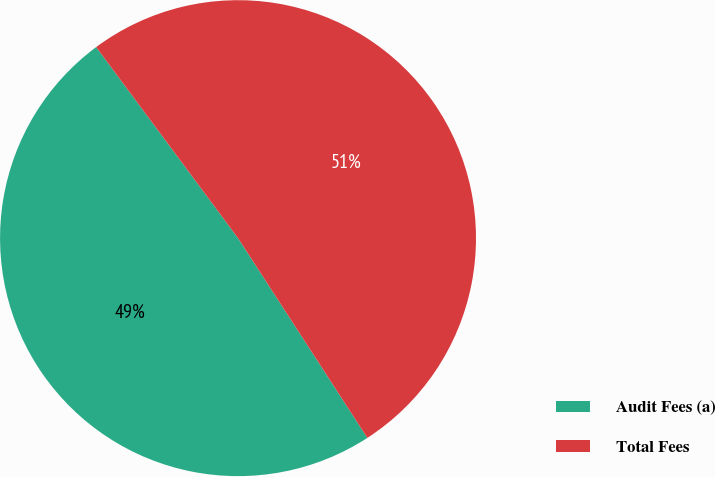Convert chart to OTSL. <chart><loc_0><loc_0><loc_500><loc_500><pie_chart><fcel>Audit Fees (a)<fcel>Total Fees<nl><fcel>48.98%<fcel>51.02%<nl></chart> 